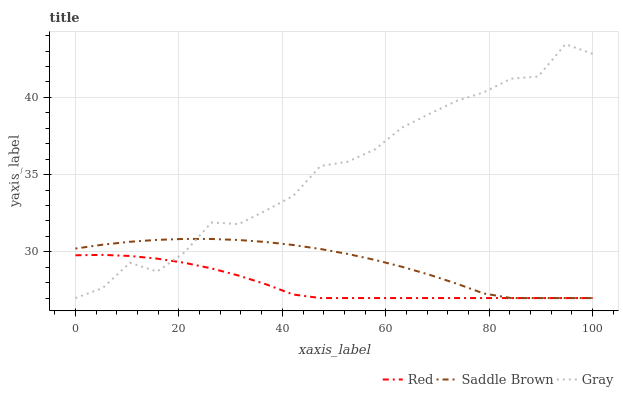Does Red have the minimum area under the curve?
Answer yes or no. Yes. Does Gray have the maximum area under the curve?
Answer yes or no. Yes. Does Saddle Brown have the minimum area under the curve?
Answer yes or no. No. Does Saddle Brown have the maximum area under the curve?
Answer yes or no. No. Is Red the smoothest?
Answer yes or no. Yes. Is Gray the roughest?
Answer yes or no. Yes. Is Saddle Brown the smoothest?
Answer yes or no. No. Is Saddle Brown the roughest?
Answer yes or no. No. Does Saddle Brown have the highest value?
Answer yes or no. No. 